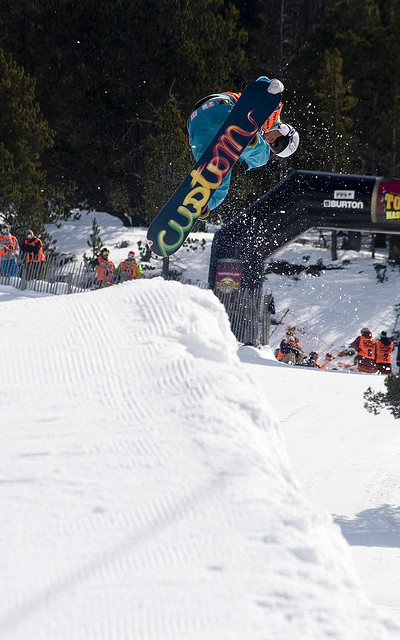Read and extract the text from this image. custom BURTON TO HAS 